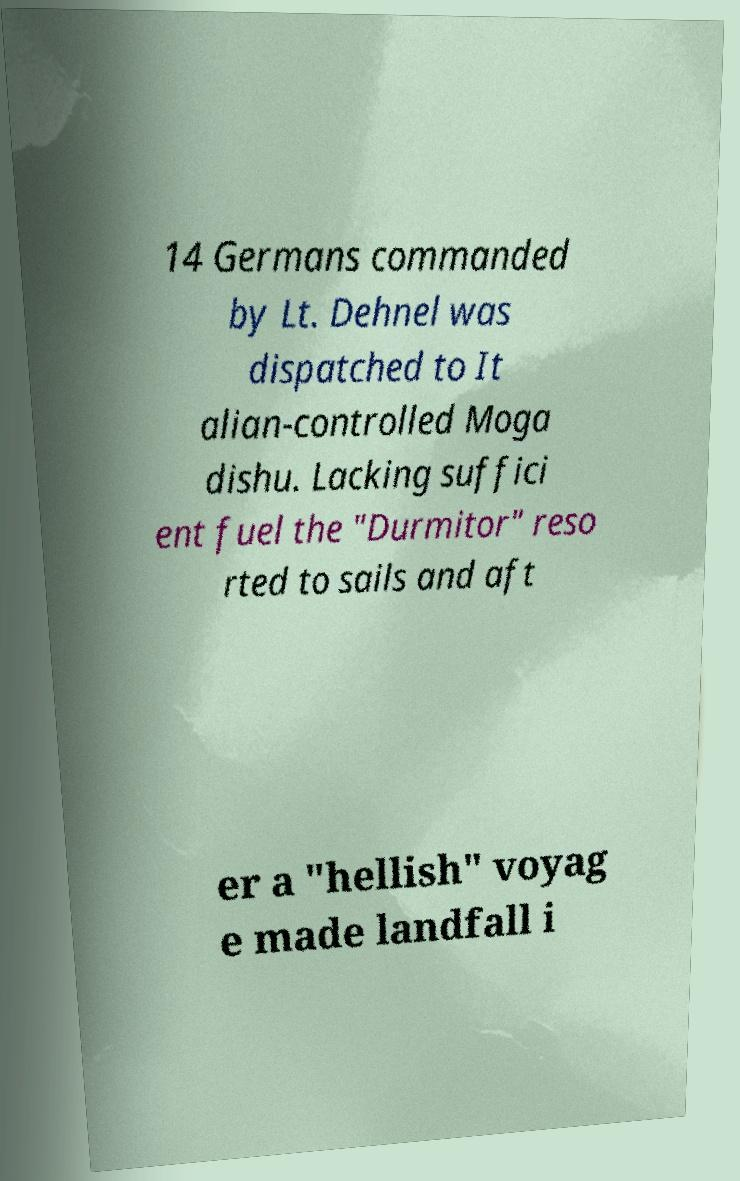What messages or text are displayed in this image? I need them in a readable, typed format. 14 Germans commanded by Lt. Dehnel was dispatched to It alian-controlled Moga dishu. Lacking suffici ent fuel the "Durmitor" reso rted to sails and aft er a "hellish" voyag e made landfall i 